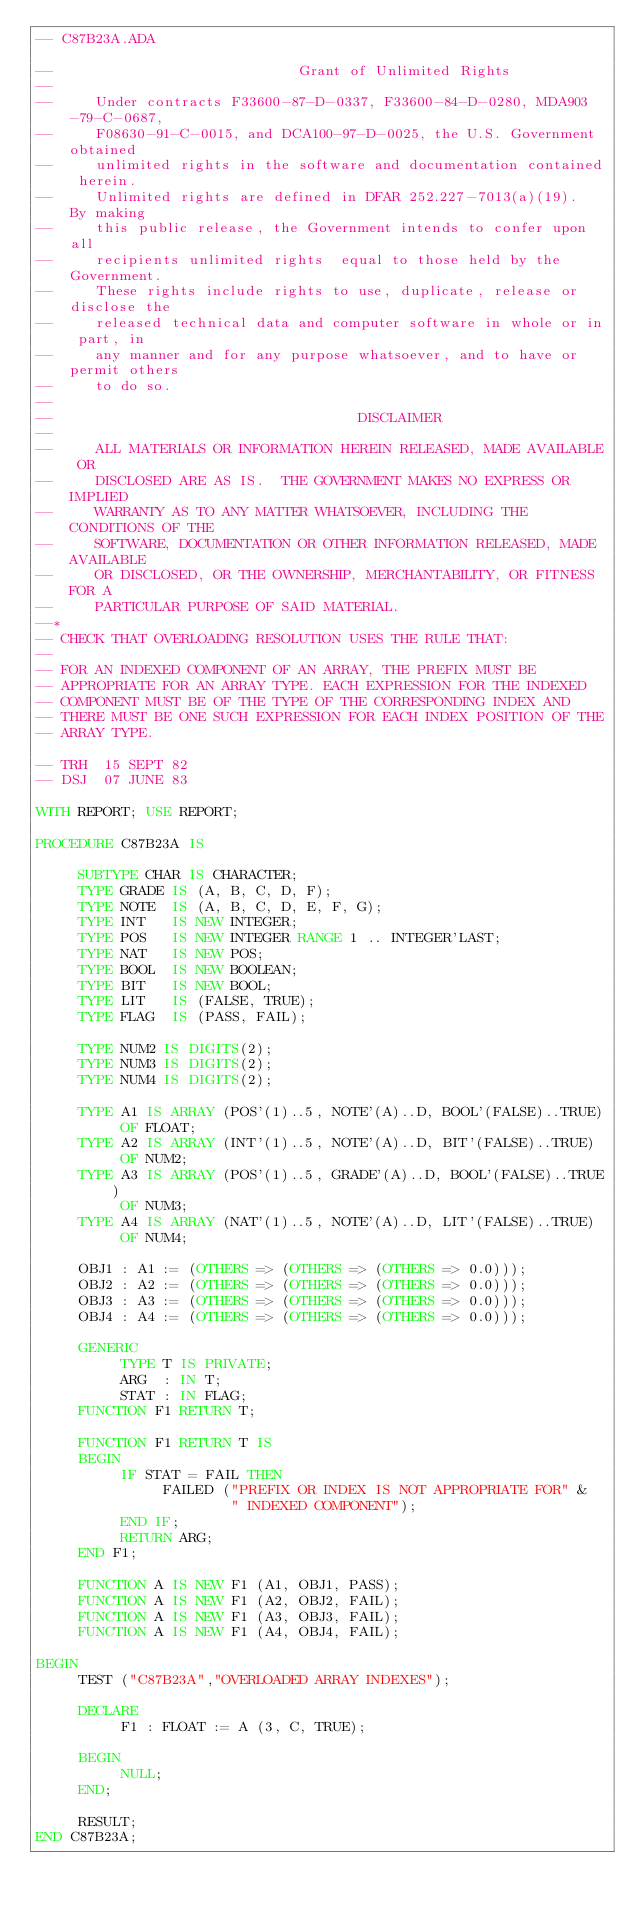<code> <loc_0><loc_0><loc_500><loc_500><_Ada_>-- C87B23A.ADA

--                             Grant of Unlimited Rights
--
--     Under contracts F33600-87-D-0337, F33600-84-D-0280, MDA903-79-C-0687,
--     F08630-91-C-0015, and DCA100-97-D-0025, the U.S. Government obtained 
--     unlimited rights in the software and documentation contained herein.
--     Unlimited rights are defined in DFAR 252.227-7013(a)(19).  By making 
--     this public release, the Government intends to confer upon all 
--     recipients unlimited rights  equal to those held by the Government.  
--     These rights include rights to use, duplicate, release or disclose the 
--     released technical data and computer software in whole or in part, in 
--     any manner and for any purpose whatsoever, and to have or permit others 
--     to do so.
--
--                                    DISCLAIMER
--
--     ALL MATERIALS OR INFORMATION HEREIN RELEASED, MADE AVAILABLE OR
--     DISCLOSED ARE AS IS.  THE GOVERNMENT MAKES NO EXPRESS OR IMPLIED 
--     WARRANTY AS TO ANY MATTER WHATSOEVER, INCLUDING THE CONDITIONS OF THE
--     SOFTWARE, DOCUMENTATION OR OTHER INFORMATION RELEASED, MADE AVAILABLE 
--     OR DISCLOSED, OR THE OWNERSHIP, MERCHANTABILITY, OR FITNESS FOR A
--     PARTICULAR PURPOSE OF SAID MATERIAL.
--*
-- CHECK THAT OVERLOADING RESOLUTION USES THE RULE THAT:
--
-- FOR AN INDEXED COMPONENT OF AN ARRAY, THE PREFIX MUST BE 
-- APPROPRIATE FOR AN ARRAY TYPE. EACH EXPRESSION FOR THE INDEXED 
-- COMPONENT MUST BE OF THE TYPE OF THE CORRESPONDING INDEX AND
-- THERE MUST BE ONE SUCH EXPRESSION FOR EACH INDEX POSITION OF THE 
-- ARRAY TYPE.
  
-- TRH  15 SEPT 82
-- DSJ  07 JUNE 83
  
WITH REPORT; USE REPORT;
   
PROCEDURE C87B23A IS

     SUBTYPE CHAR IS CHARACTER;
     TYPE GRADE IS (A, B, C, D, F);
     TYPE NOTE  IS (A, B, C, D, E, F, G);
     TYPE INT   IS NEW INTEGER;
     TYPE POS   IS NEW INTEGER RANGE 1 .. INTEGER'LAST;
     TYPE NAT   IS NEW POS;
     TYPE BOOL  IS NEW BOOLEAN;
     TYPE BIT   IS NEW BOOL;
     TYPE LIT   IS (FALSE, TRUE);
     TYPE FLAG  IS (PASS, FAIL);

     TYPE NUM2 IS DIGITS(2);
     TYPE NUM3 IS DIGITS(2);
     TYPE NUM4 IS DIGITS(2);

     TYPE A1 IS ARRAY (POS'(1)..5, NOTE'(A)..D, BOOL'(FALSE)..TRUE)
          OF FLOAT;
     TYPE A2 IS ARRAY (INT'(1)..5, NOTE'(A)..D, BIT'(FALSE)..TRUE)
          OF NUM2;
     TYPE A3 IS ARRAY (POS'(1)..5, GRADE'(A)..D, BOOL'(FALSE)..TRUE)
          OF NUM3;
     TYPE A4 IS ARRAY (NAT'(1)..5, NOTE'(A)..D, LIT'(FALSE)..TRUE)
          OF NUM4;
     
     OBJ1 : A1 := (OTHERS => (OTHERS => (OTHERS => 0.0)));
     OBJ2 : A2 := (OTHERS => (OTHERS => (OTHERS => 0.0)));
     OBJ3 : A3 := (OTHERS => (OTHERS => (OTHERS => 0.0)));
     OBJ4 : A4 := (OTHERS => (OTHERS => (OTHERS => 0.0)));

     GENERIC
          TYPE T IS PRIVATE;
          ARG  : IN T;
          STAT : IN FLAG;
     FUNCTION F1 RETURN T;
 
     FUNCTION F1 RETURN T IS
     BEGIN 
          IF STAT = FAIL THEN 
               FAILED ("PREFIX OR INDEX IS NOT APPROPRIATE FOR" &
                       " INDEXED COMPONENT");
          END IF;
          RETURN ARG;
     END F1;
  
     FUNCTION A IS NEW F1 (A1, OBJ1, PASS);
     FUNCTION A IS NEW F1 (A2, OBJ2, FAIL);
     FUNCTION A IS NEW F1 (A3, OBJ3, FAIL);
     FUNCTION A IS NEW F1 (A4, OBJ4, FAIL);
  
BEGIN
     TEST ("C87B23A","OVERLOADED ARRAY INDEXES");
    
     DECLARE
          F1 : FLOAT := A (3, C, TRUE);
   
     BEGIN
          NULL;
     END;
 
     RESULT;
END C87B23A;
</code> 